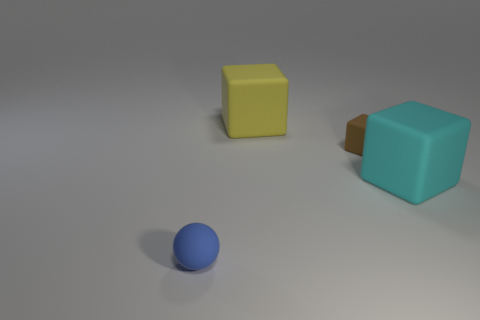Subtract all yellow cubes. How many cubes are left? 2 Add 4 big cyan things. How many objects exist? 8 Subtract all blocks. How many objects are left? 1 Add 3 small blue rubber balls. How many small blue rubber balls are left? 4 Add 4 small cylinders. How many small cylinders exist? 4 Subtract 0 green cylinders. How many objects are left? 4 Subtract all big brown matte cubes. Subtract all tiny rubber spheres. How many objects are left? 3 